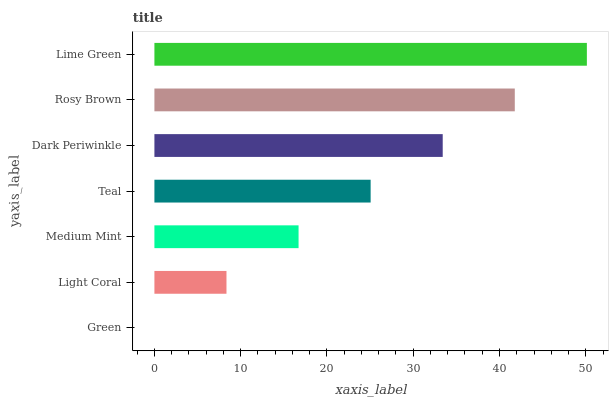Is Green the minimum?
Answer yes or no. Yes. Is Lime Green the maximum?
Answer yes or no. Yes. Is Light Coral the minimum?
Answer yes or no. No. Is Light Coral the maximum?
Answer yes or no. No. Is Light Coral greater than Green?
Answer yes or no. Yes. Is Green less than Light Coral?
Answer yes or no. Yes. Is Green greater than Light Coral?
Answer yes or no. No. Is Light Coral less than Green?
Answer yes or no. No. Is Teal the high median?
Answer yes or no. Yes. Is Teal the low median?
Answer yes or no. Yes. Is Medium Mint the high median?
Answer yes or no. No. Is Medium Mint the low median?
Answer yes or no. No. 